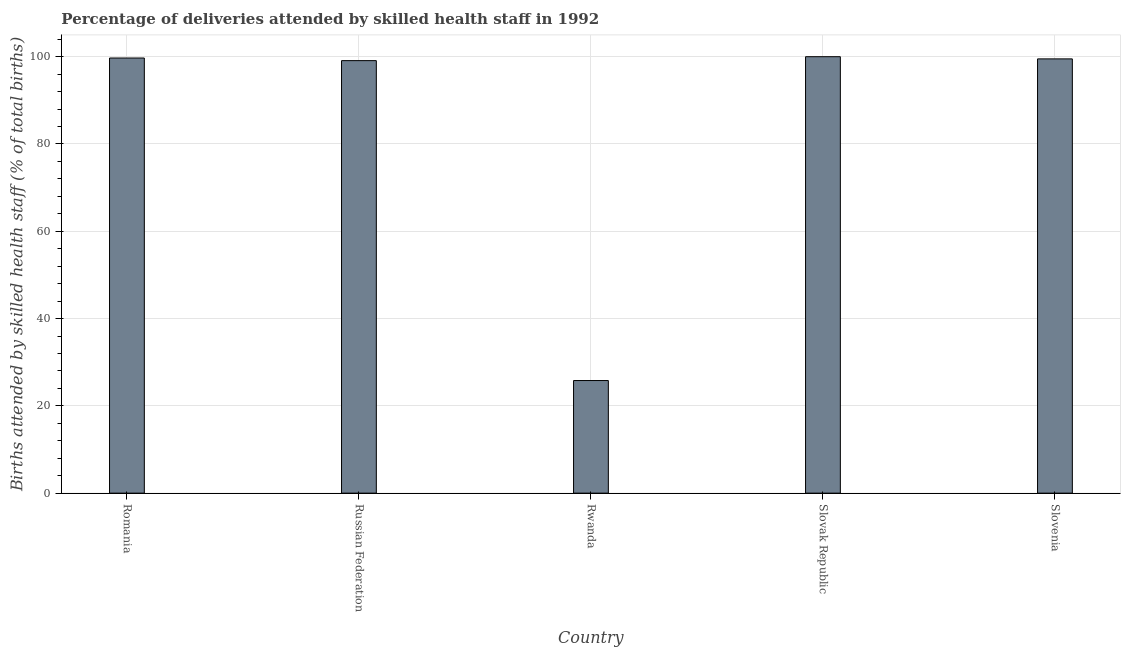Does the graph contain grids?
Provide a succinct answer. Yes. What is the title of the graph?
Provide a succinct answer. Percentage of deliveries attended by skilled health staff in 1992. What is the label or title of the Y-axis?
Give a very brief answer. Births attended by skilled health staff (% of total births). What is the number of births attended by skilled health staff in Russian Federation?
Offer a terse response. 99.1. Across all countries, what is the maximum number of births attended by skilled health staff?
Give a very brief answer. 100. Across all countries, what is the minimum number of births attended by skilled health staff?
Your answer should be compact. 25.8. In which country was the number of births attended by skilled health staff maximum?
Give a very brief answer. Slovak Republic. In which country was the number of births attended by skilled health staff minimum?
Offer a very short reply. Rwanda. What is the sum of the number of births attended by skilled health staff?
Offer a terse response. 424.1. What is the difference between the number of births attended by skilled health staff in Russian Federation and Rwanda?
Offer a very short reply. 73.3. What is the average number of births attended by skilled health staff per country?
Offer a terse response. 84.82. What is the median number of births attended by skilled health staff?
Make the answer very short. 99.5. What is the difference between the highest and the lowest number of births attended by skilled health staff?
Keep it short and to the point. 74.2. In how many countries, is the number of births attended by skilled health staff greater than the average number of births attended by skilled health staff taken over all countries?
Your answer should be very brief. 4. What is the difference between two consecutive major ticks on the Y-axis?
Give a very brief answer. 20. What is the Births attended by skilled health staff (% of total births) of Romania?
Your response must be concise. 99.7. What is the Births attended by skilled health staff (% of total births) in Russian Federation?
Your answer should be compact. 99.1. What is the Births attended by skilled health staff (% of total births) of Rwanda?
Your answer should be very brief. 25.8. What is the Births attended by skilled health staff (% of total births) of Slovenia?
Your response must be concise. 99.5. What is the difference between the Births attended by skilled health staff (% of total births) in Romania and Russian Federation?
Ensure brevity in your answer.  0.6. What is the difference between the Births attended by skilled health staff (% of total births) in Romania and Rwanda?
Provide a short and direct response. 73.9. What is the difference between the Births attended by skilled health staff (% of total births) in Romania and Slovenia?
Make the answer very short. 0.2. What is the difference between the Births attended by skilled health staff (% of total births) in Russian Federation and Rwanda?
Your answer should be very brief. 73.3. What is the difference between the Births attended by skilled health staff (% of total births) in Russian Federation and Slovenia?
Provide a short and direct response. -0.4. What is the difference between the Births attended by skilled health staff (% of total births) in Rwanda and Slovak Republic?
Your response must be concise. -74.2. What is the difference between the Births attended by skilled health staff (% of total births) in Rwanda and Slovenia?
Offer a terse response. -73.7. What is the difference between the Births attended by skilled health staff (% of total births) in Slovak Republic and Slovenia?
Offer a very short reply. 0.5. What is the ratio of the Births attended by skilled health staff (% of total births) in Romania to that in Rwanda?
Your answer should be compact. 3.86. What is the ratio of the Births attended by skilled health staff (% of total births) in Romania to that in Slovenia?
Keep it short and to the point. 1. What is the ratio of the Births attended by skilled health staff (% of total births) in Russian Federation to that in Rwanda?
Provide a succinct answer. 3.84. What is the ratio of the Births attended by skilled health staff (% of total births) in Russian Federation to that in Slovak Republic?
Your answer should be very brief. 0.99. What is the ratio of the Births attended by skilled health staff (% of total births) in Russian Federation to that in Slovenia?
Your response must be concise. 1. What is the ratio of the Births attended by skilled health staff (% of total births) in Rwanda to that in Slovak Republic?
Your response must be concise. 0.26. What is the ratio of the Births attended by skilled health staff (% of total births) in Rwanda to that in Slovenia?
Give a very brief answer. 0.26. What is the ratio of the Births attended by skilled health staff (% of total births) in Slovak Republic to that in Slovenia?
Keep it short and to the point. 1. 